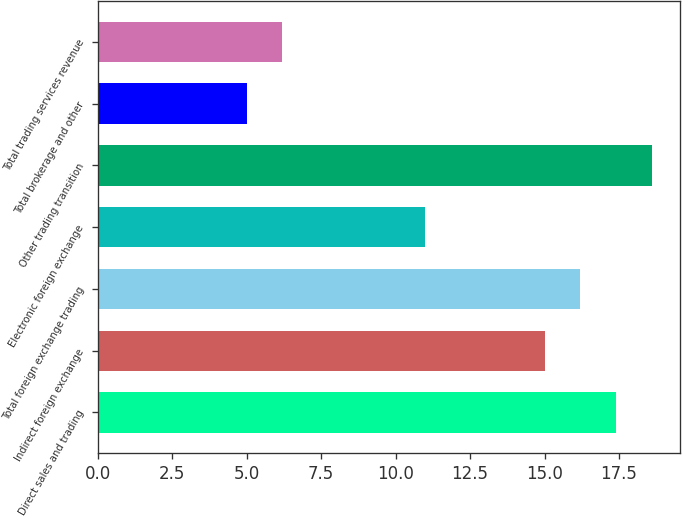<chart> <loc_0><loc_0><loc_500><loc_500><bar_chart><fcel>Direct sales and trading<fcel>Indirect foreign exchange<fcel>Total foreign exchange trading<fcel>Electronic foreign exchange<fcel>Other trading transition<fcel>Total brokerage and other<fcel>Total trading services revenue<nl><fcel>17.4<fcel>15<fcel>16.2<fcel>11<fcel>18.6<fcel>5<fcel>6.2<nl></chart> 